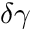<formula> <loc_0><loc_0><loc_500><loc_500>\delta \gamma</formula> 